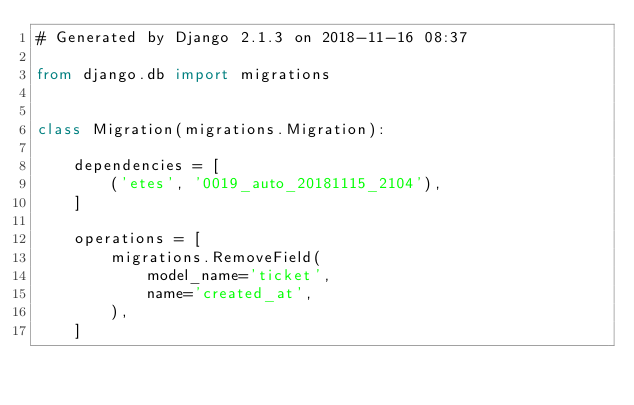<code> <loc_0><loc_0><loc_500><loc_500><_Python_># Generated by Django 2.1.3 on 2018-11-16 08:37

from django.db import migrations


class Migration(migrations.Migration):

    dependencies = [
        ('etes', '0019_auto_20181115_2104'),
    ]

    operations = [
        migrations.RemoveField(
            model_name='ticket',
            name='created_at',
        ),
    ]
</code> 